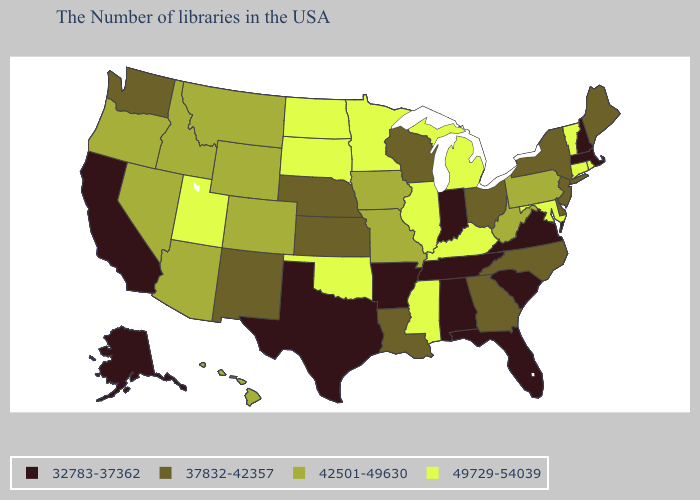How many symbols are there in the legend?
Short answer required. 4. What is the lowest value in the Northeast?
Short answer required. 32783-37362. Name the states that have a value in the range 32783-37362?
Answer briefly. Massachusetts, New Hampshire, Virginia, South Carolina, Florida, Indiana, Alabama, Tennessee, Arkansas, Texas, California, Alaska. How many symbols are there in the legend?
Concise answer only. 4. Name the states that have a value in the range 49729-54039?
Be succinct. Rhode Island, Vermont, Connecticut, Maryland, Michigan, Kentucky, Illinois, Mississippi, Minnesota, Oklahoma, South Dakota, North Dakota, Utah. What is the value of Alaska?
Concise answer only. 32783-37362. Does Maryland have the highest value in the USA?
Answer briefly. Yes. Name the states that have a value in the range 32783-37362?
Short answer required. Massachusetts, New Hampshire, Virginia, South Carolina, Florida, Indiana, Alabama, Tennessee, Arkansas, Texas, California, Alaska. How many symbols are there in the legend?
Answer briefly. 4. What is the highest value in the USA?
Concise answer only. 49729-54039. Among the states that border Connecticut , does Rhode Island have the highest value?
Concise answer only. Yes. What is the value of North Carolina?
Keep it brief. 37832-42357. What is the lowest value in states that border Nebraska?
Short answer required. 37832-42357. Does Louisiana have the highest value in the USA?
Be succinct. No. Name the states that have a value in the range 49729-54039?
Concise answer only. Rhode Island, Vermont, Connecticut, Maryland, Michigan, Kentucky, Illinois, Mississippi, Minnesota, Oklahoma, South Dakota, North Dakota, Utah. 